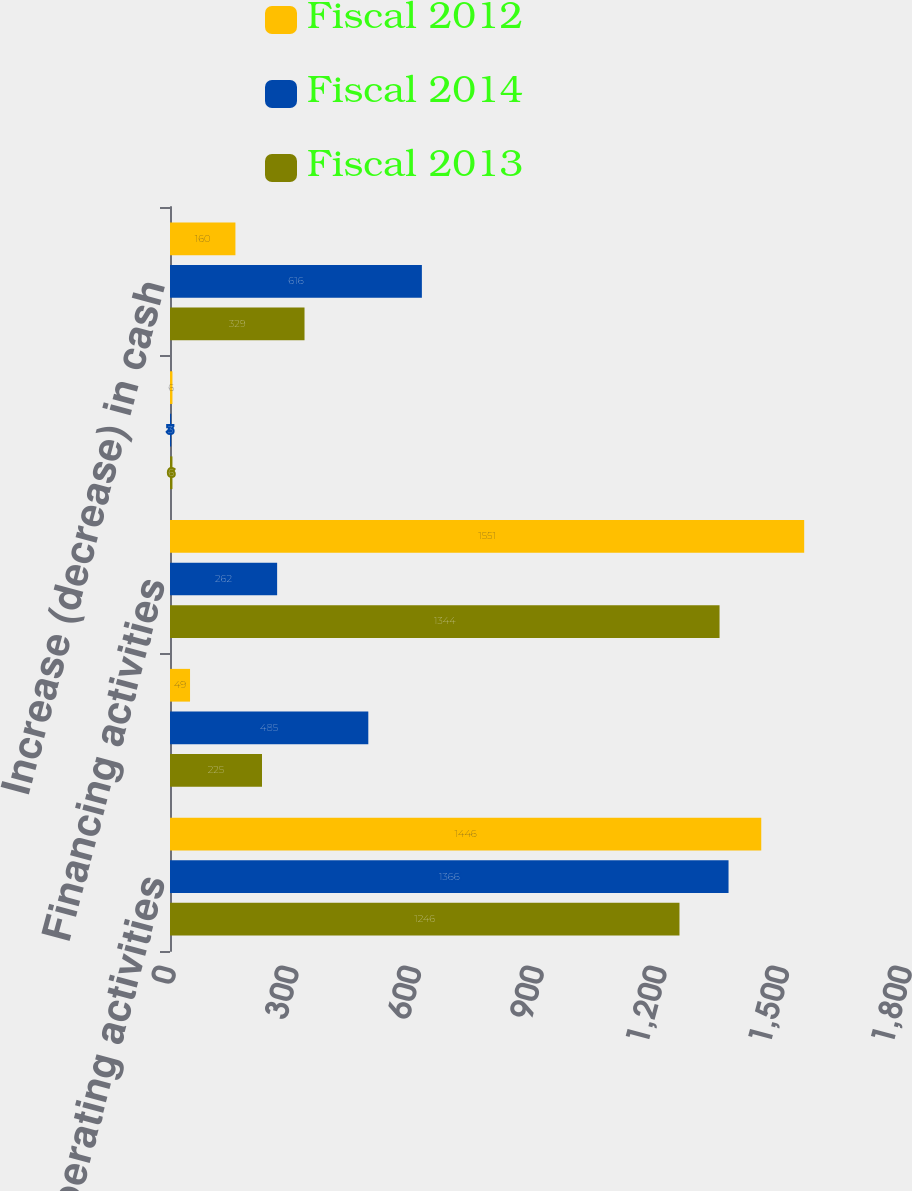Convert chart to OTSL. <chart><loc_0><loc_0><loc_500><loc_500><stacked_bar_chart><ecel><fcel>Operating activities<fcel>Investing activities<fcel>Financing activities<fcel>Effect of exchange rate<fcel>Increase (decrease) in cash<nl><fcel>Fiscal 2012<fcel>1446<fcel>49<fcel>1551<fcel>6<fcel>160<nl><fcel>Fiscal 2014<fcel>1366<fcel>485<fcel>262<fcel>3<fcel>616<nl><fcel>Fiscal 2013<fcel>1246<fcel>225<fcel>1344<fcel>6<fcel>329<nl></chart> 